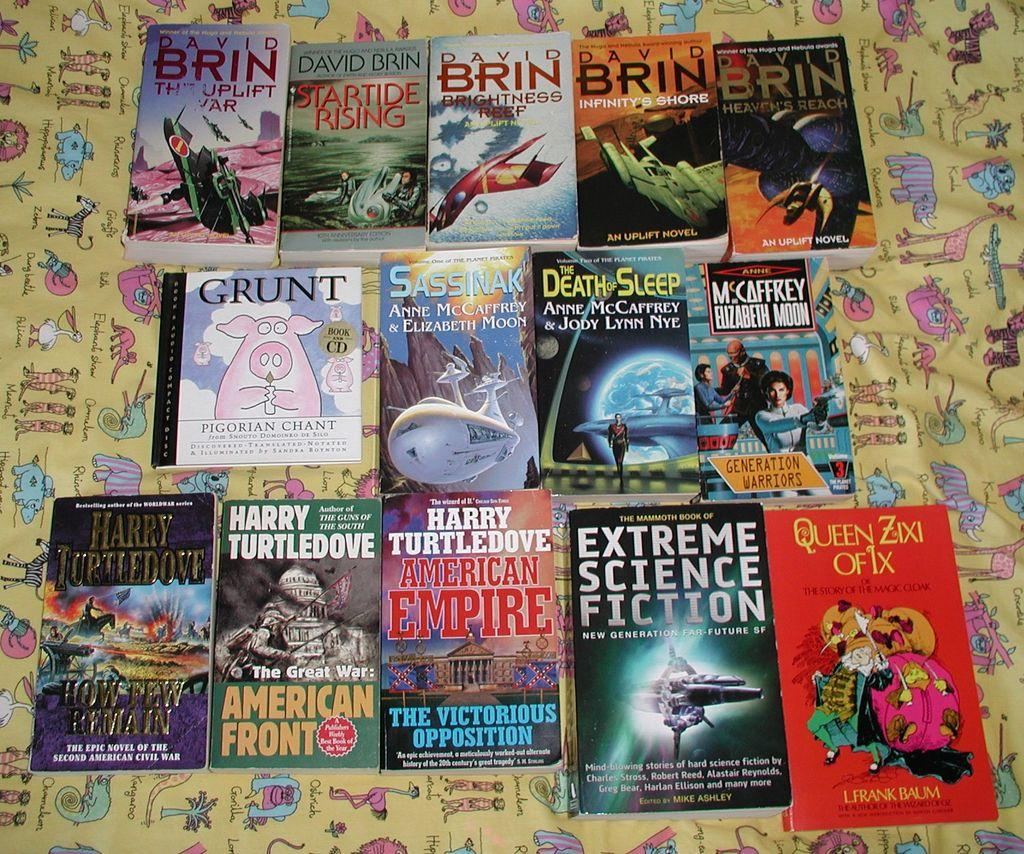<image>
Present a compact description of the photo's key features. 14 books laid out on a table, 5 of which were written by David Brin. 